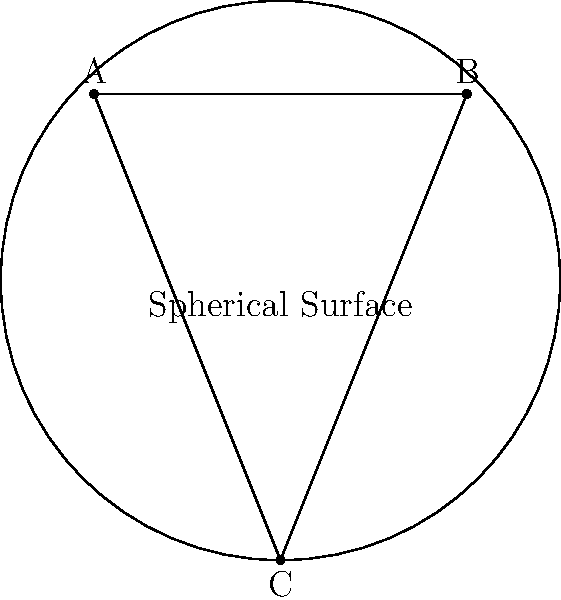In a reality show challenge, contestants must navigate a spherical surface. The challenge involves traversing a triangle ABC on this surface. If the sum of the interior angles of this triangle is measured to be 210°, what is the radius of the sphere given that each degree of excess over 180° in a spherical triangle corresponds to $\frac{R^2}{720\pi}$ square units of surface area, where R is the radius? Let's approach this step-by-step:

1) In Euclidean geometry, the sum of interior angles of a triangle is always 180°. The excess over 180° in this case is:
   $210° - 180° = 30°$

2) We're given that each degree of excess corresponds to $\frac{R^2}{720\pi}$ square units of surface area.

3) Therefore, the total excess area (E) is:
   $E = 30 \cdot \frac{R^2}{720\pi}$ square units

4) We also know that the surface area of a sphere is $4\pi R^2$.

5) The ratio of the excess area to the total surface area of the sphere is equal to the ratio of the excess angle to 720° (as there are 720° in a full spherical excess). This gives us the equation:

   $\frac{E}{4\pi R^2} = \frac{30}{720}$

6) Substituting the expression for E:

   $\frac{30 \cdot \frac{R^2}{720\pi}}{4\pi R^2} = \frac{30}{720}$

7) Simplifying:

   $\frac{30}{720\pi} \cdot \frac{1}{4\pi} = \frac{30}{720}$

8) The R² terms cancel out, leaving us with:

   $\frac{30}{2880\pi^2} = \frac{30}{720}$

9) Solving for π:

   $\pi^2 = 4$
   $\pi = 2$

10) Therefore, the radius R that satisfies this equation is the one where π = 2.
Answer: $R = \frac{C}{4}$, where C is the circumference of the sphere 